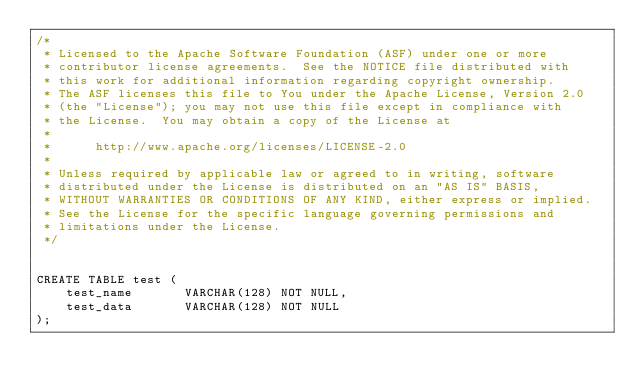<code> <loc_0><loc_0><loc_500><loc_500><_SQL_>/*
 * Licensed to the Apache Software Foundation (ASF) under one or more
 * contributor license agreements.  See the NOTICE file distributed with
 * this work for additional information regarding copyright ownership.
 * The ASF licenses this file to You under the Apache License, Version 2.0
 * (the "License"); you may not use this file except in compliance with
 * the License.  You may obtain a copy of the License at
 *
 *      http://www.apache.org/licenses/LICENSE-2.0
 *
 * Unless required by applicable law or agreed to in writing, software
 * distributed under the License is distributed on an "AS IS" BASIS,
 * WITHOUT WARRANTIES OR CONDITIONS OF ANY KIND, either express or implied.
 * See the License for the specific language governing permissions and
 * limitations under the License.
 */


CREATE TABLE test (
    test_name       VARCHAR(128) NOT NULL,
    test_data       VARCHAR(128) NOT NULL
);</code> 